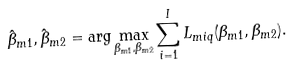<formula> <loc_0><loc_0><loc_500><loc_500>\hat { \beta } _ { m 1 } , \hat { \beta } _ { m 2 } = \arg \max _ { \beta _ { m 1 } , \beta _ { m 2 } } \sum ^ { I } _ { i = 1 } L _ { m i q } ( \beta _ { m 1 } , \beta _ { m 2 } ) .</formula> 